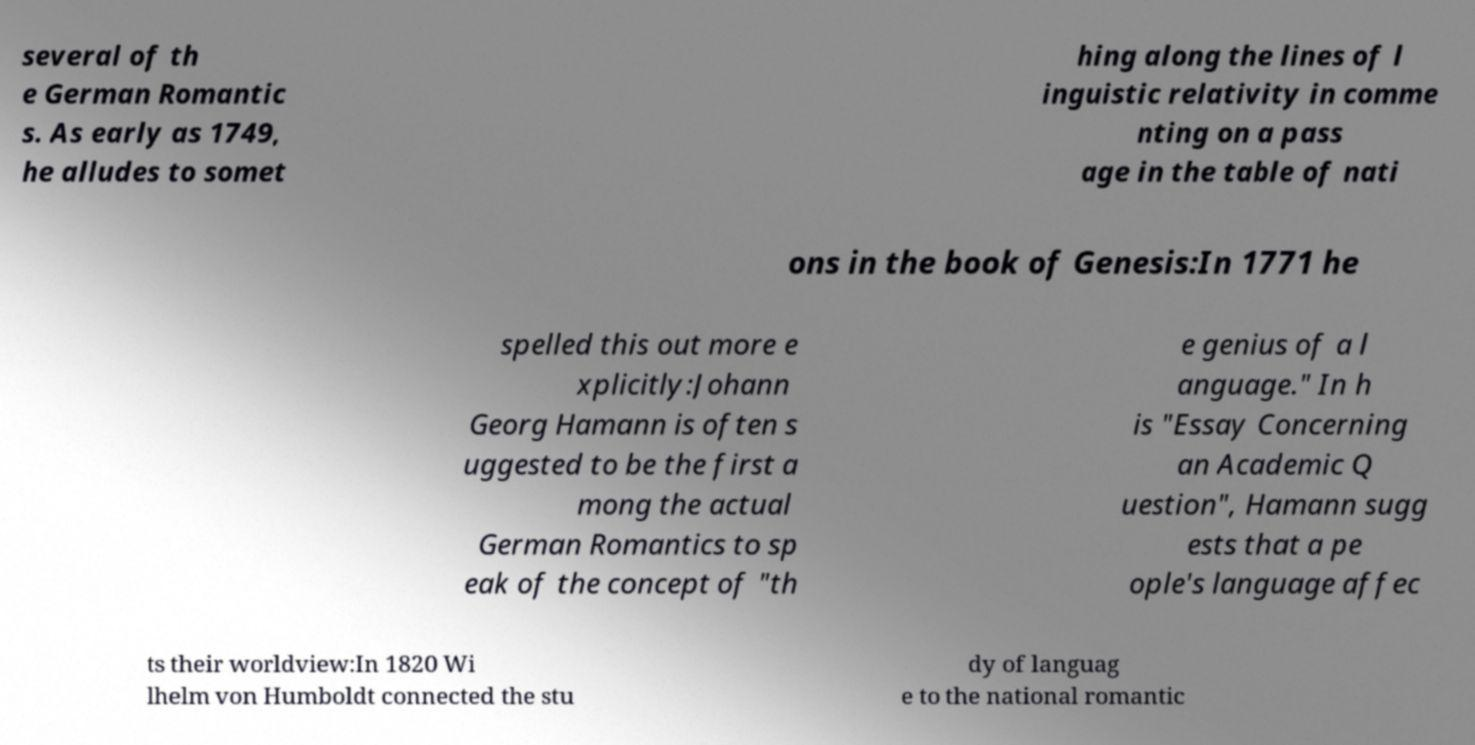Could you assist in decoding the text presented in this image and type it out clearly? several of th e German Romantic s. As early as 1749, he alludes to somet hing along the lines of l inguistic relativity in comme nting on a pass age in the table of nati ons in the book of Genesis:In 1771 he spelled this out more e xplicitly:Johann Georg Hamann is often s uggested to be the first a mong the actual German Romantics to sp eak of the concept of "th e genius of a l anguage." In h is "Essay Concerning an Academic Q uestion", Hamann sugg ests that a pe ople's language affec ts their worldview:In 1820 Wi lhelm von Humboldt connected the stu dy of languag e to the national romantic 